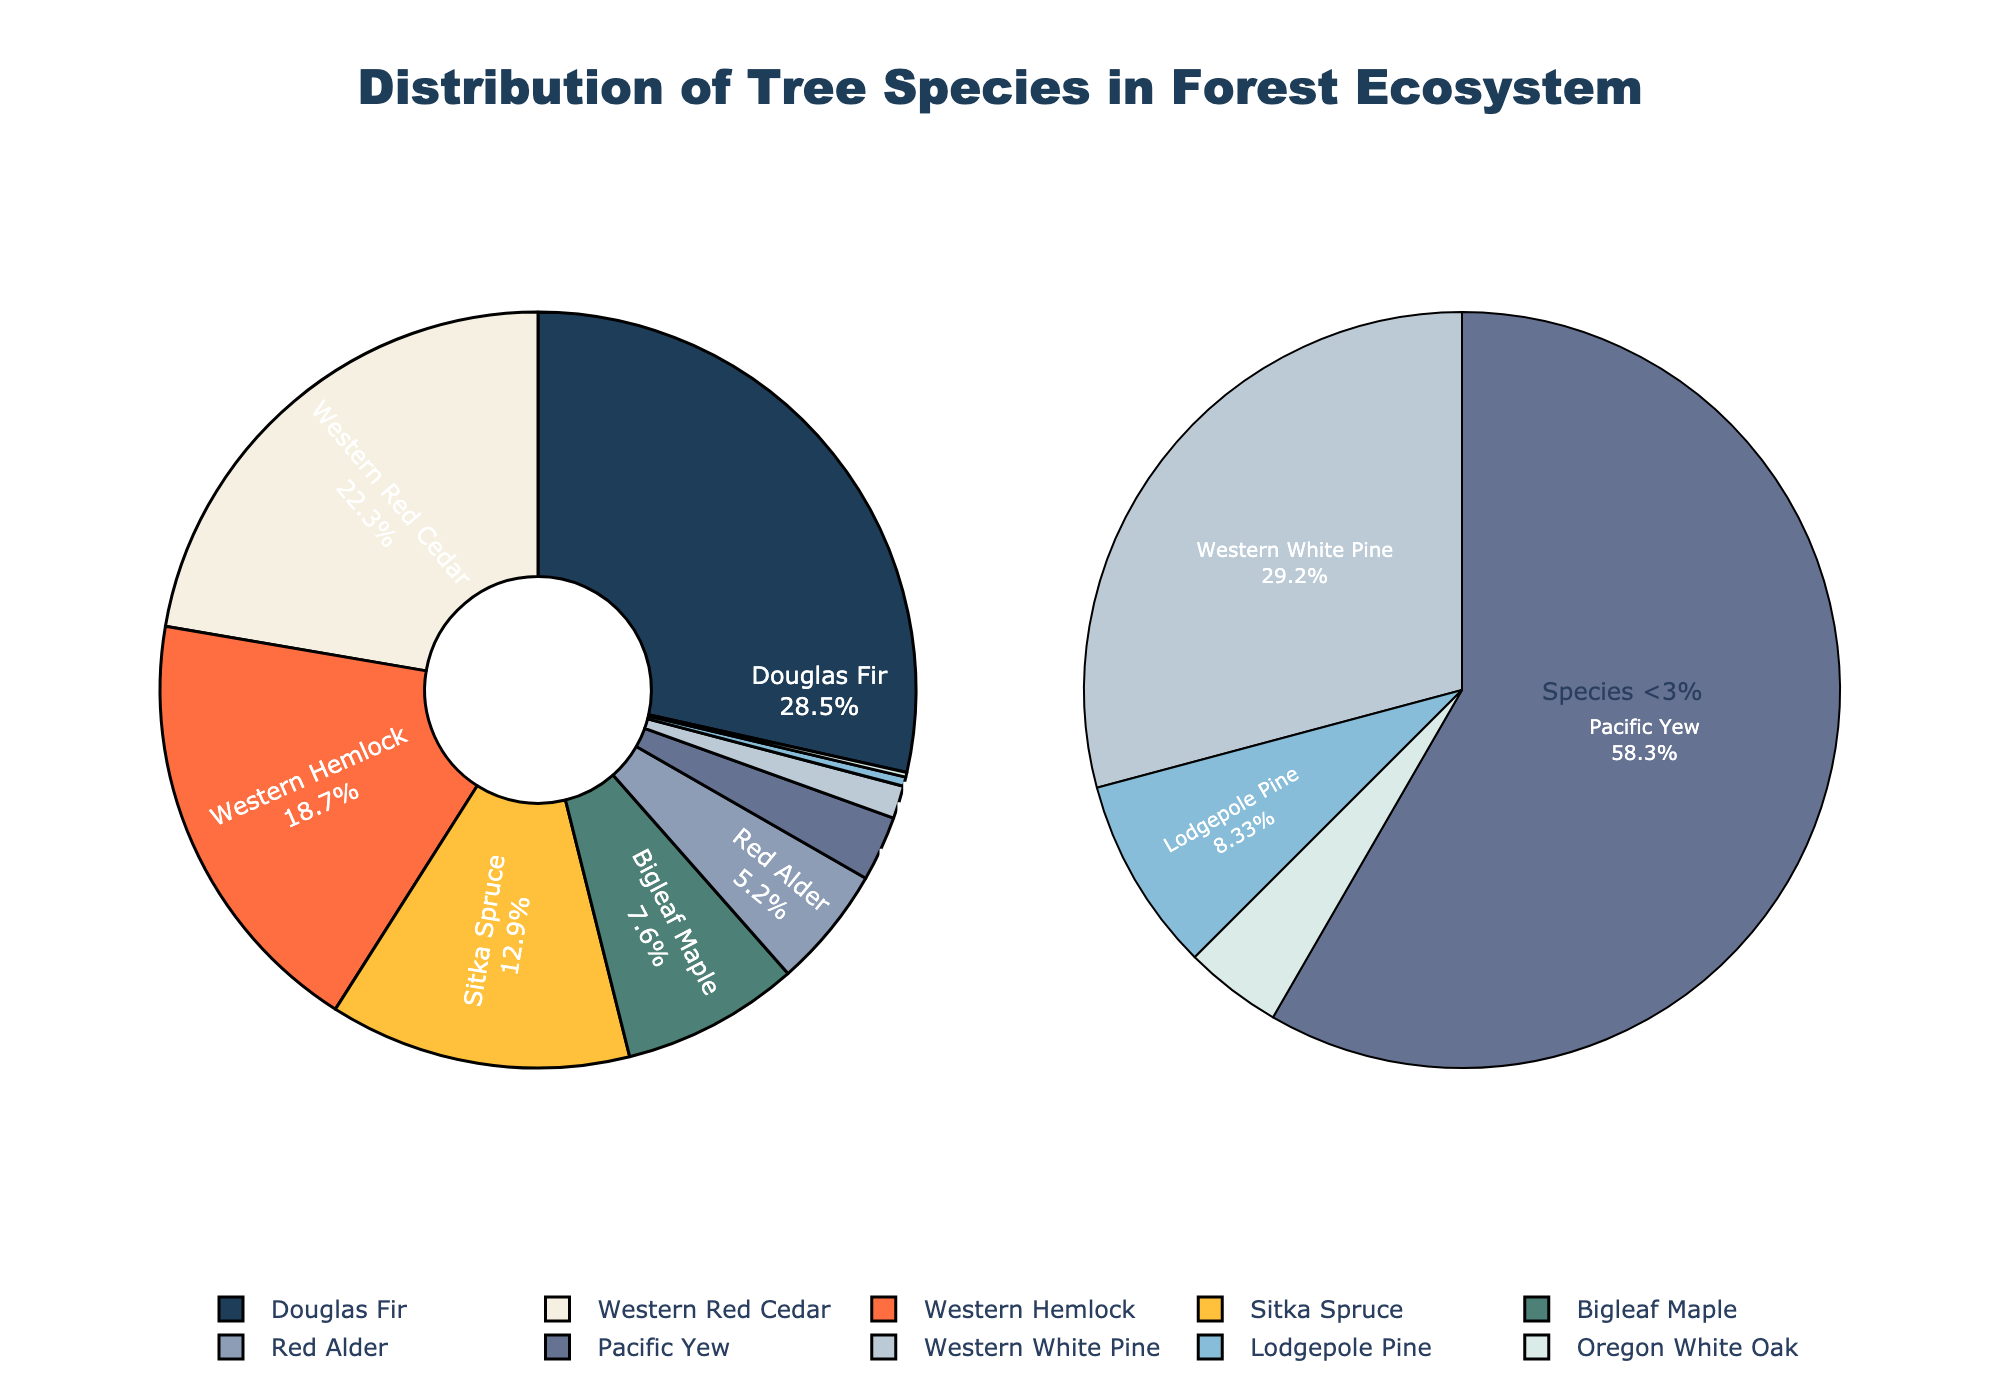Which tree species has the highest percentage in the forest ecosystem? The main pie chart shows percentages for each species. Douglas Fir has the largest segment.
Answer: Douglas Fir What is the combined percentage of Western Red Cedar and Western Hemlock? From the main pie chart, Western Red Cedar is 22.3% and Western Hemlock is 18.7%. Adding them together: 22.3% + 18.7% = 41%
Answer: 41% Which species has the smallest percentage in this forest ecosystem? In the main pie chart, the smallest segment by percentage is for Oregon White Oak.
Answer: Oregon White Oak Is Sitka Spruce more or less common than Western Hemlock? Sitka Spruce is 12.9% and Western Hemlock is 18.7% in the pie chart. Sitka Spruce is less common.
Answer: Less common Which species are displayed in the smaller pie chart, and what is their combined percentage? The smaller pie chart shows species with percentages less than 3%. These are Pacific Yew (2.8%), Western White Pine (1.4%), Lodgepole Pine (0.4%), and Oregon White Oak (0.2%). Their combined percentage is 2.8% + 1.4% + 0.4% + 0.2% = 4.8%
Answer: 4.8% How does the percentage of Bigleaf Maple compare to that of Red Alder? From the main pie chart, Bigleaf Maple is 7.6% and Red Alder is 5.2%. Bigleaf Maple is more common.
Answer: Bigleaf Maple is more common What is the total percentage of the three least common species? The three least common species in the pie chart are Oregon White Oak (0.2%), Lodgepole Pine (0.4%), and Western White Pine (1.4%). Total percentage is 0.2% + 0.4% + 1.4% = 2%
Answer: 2% Which colors represent Douglas Fir and Sitka Spruce in the main pie chart? Douglas Fir is represented by the dark blue color, and Sitka Spruce is represented by a brown color.
Answer: Dark blue for Douglas Fir and brown for Sitka Spruce If Bigleaf Maple's percentage were doubled, would it surpass Western Red Cedar's percentage? Bigleaf Maple is currently 7.6%. Doubling it: 7.6% * 2 = 15.2%. Western Red Cedar is 22.3%. Since 15.2% < 22.3%, it would not surpass Western Red Cedar.
Answer: No What percentage of the total forest ecosystem is accounted for by species with more than 10% distribution each? The species with more than 10% distribution each are Douglas Fir (28.5%), Western Red Cedar (22.3%), Western Hemlock (18.7%), and Sitka Spruce (12.9%). Adding these: 28.5% + 22.3% + 18.7% + 12.9% = 82.4%
Answer: 82.4% 